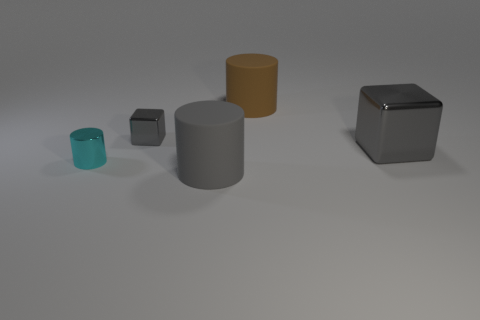Add 5 small purple metallic balls. How many objects exist? 10 Subtract all large cylinders. How many cylinders are left? 1 Subtract all blocks. How many objects are left? 3 Add 4 gray metal cubes. How many gray metal cubes are left? 6 Add 5 purple objects. How many purple objects exist? 5 Subtract all brown cylinders. How many cylinders are left? 2 Subtract 0 cyan balls. How many objects are left? 5 Subtract 1 cubes. How many cubes are left? 1 Subtract all yellow cylinders. Subtract all yellow spheres. How many cylinders are left? 3 Subtract all gray matte cylinders. Subtract all gray metal blocks. How many objects are left? 2 